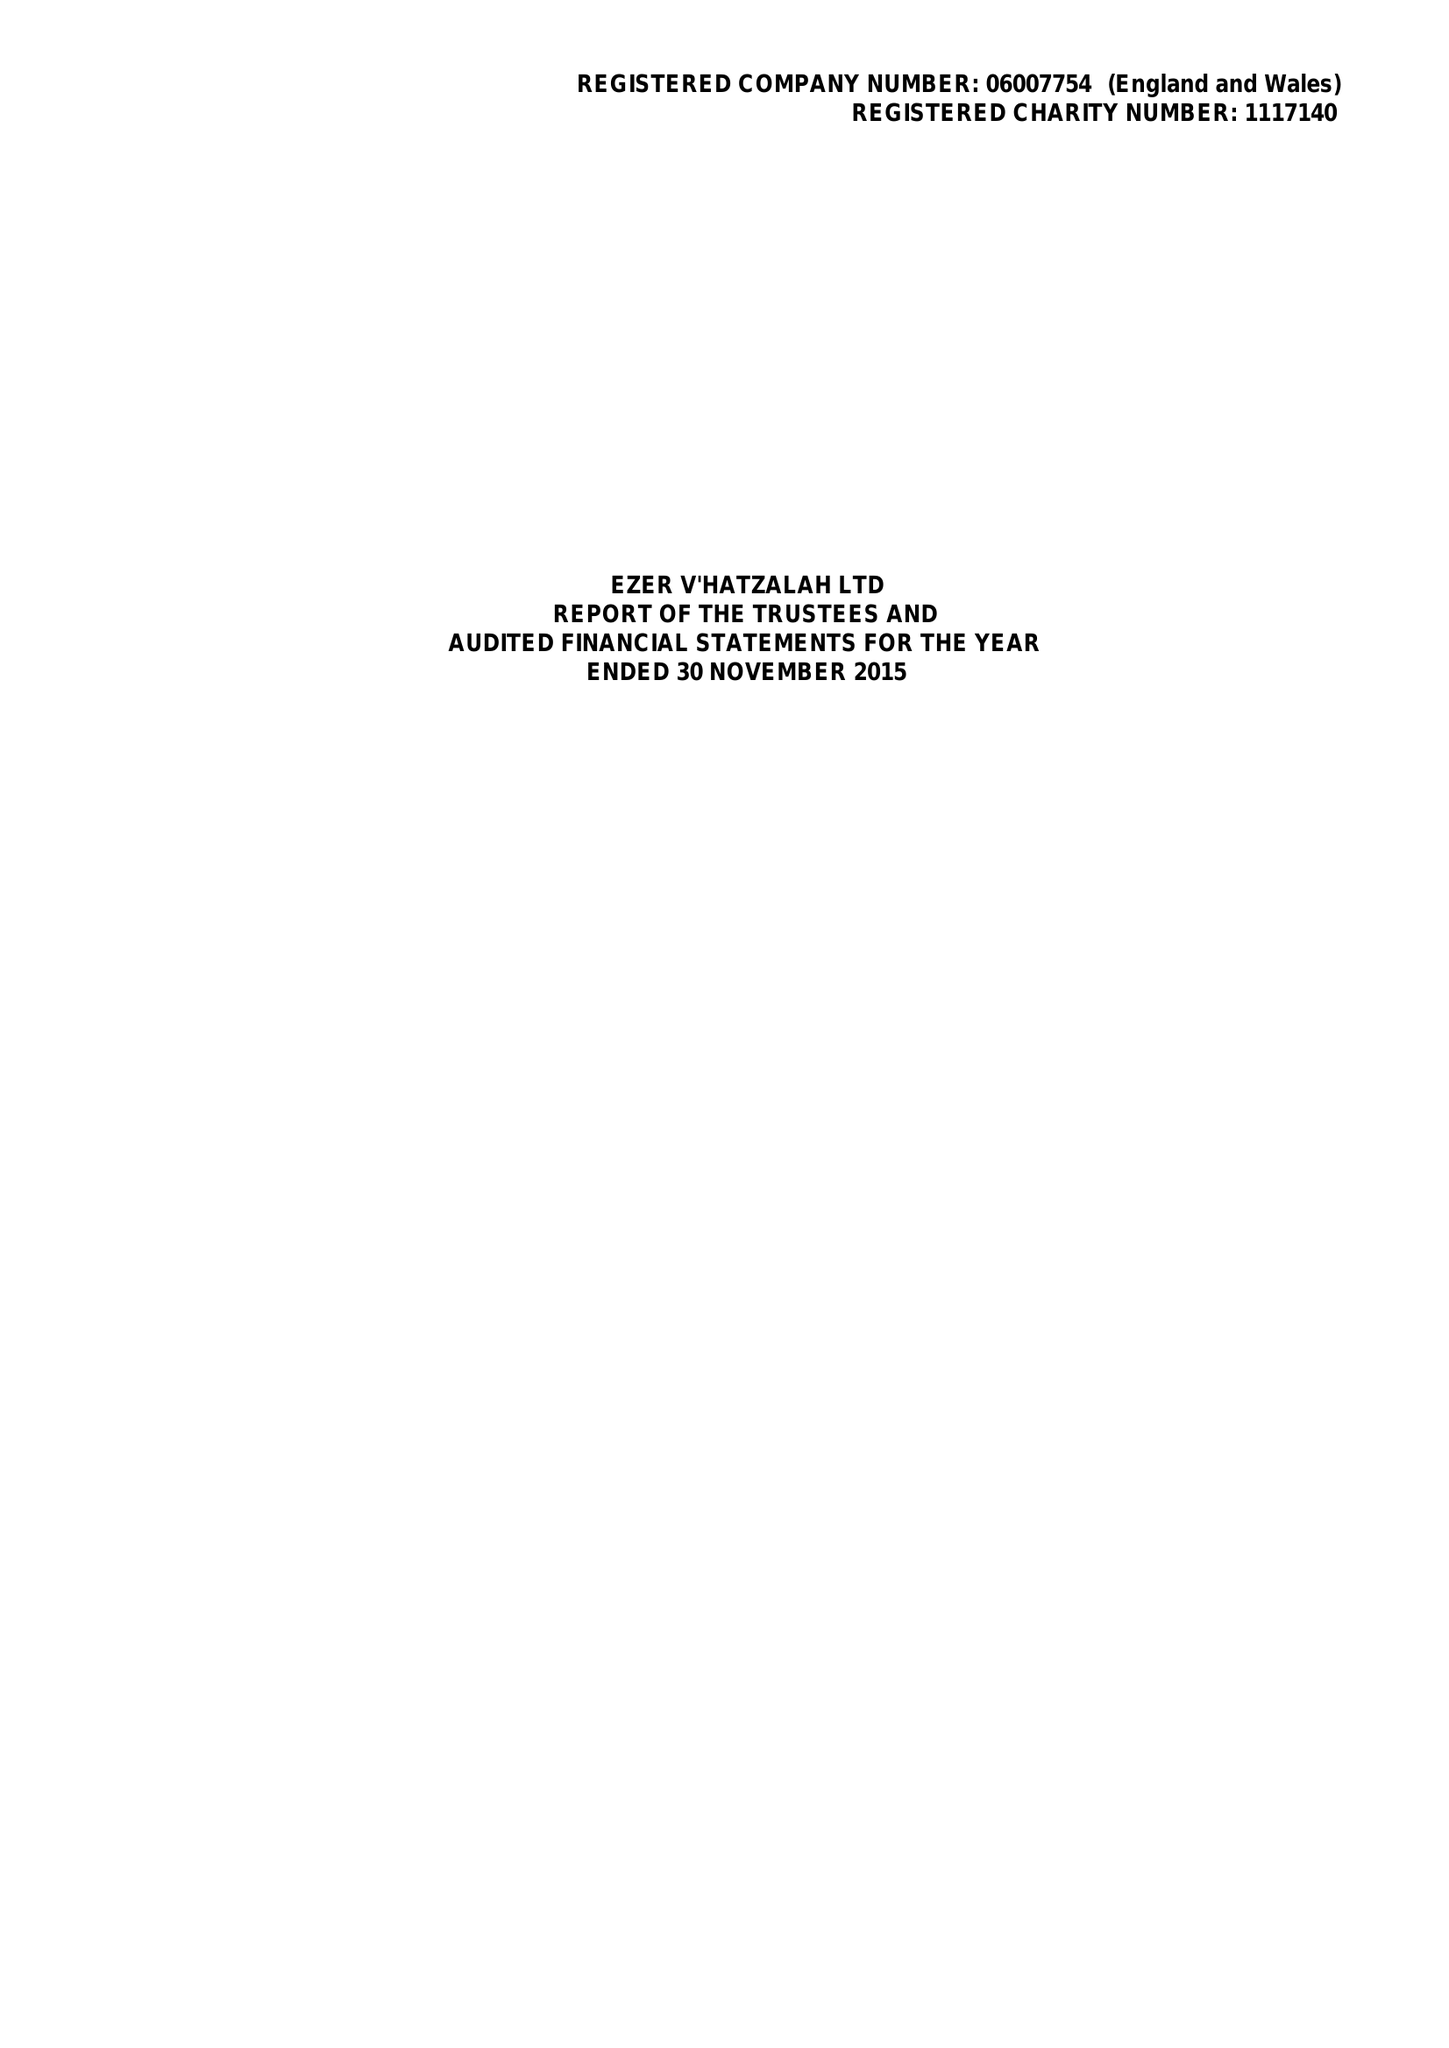What is the value for the address__post_town?
Answer the question using a single word or phrase. LONDON 